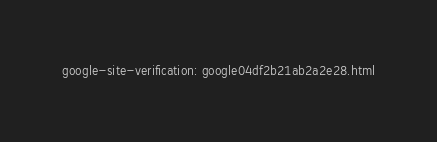<code> <loc_0><loc_0><loc_500><loc_500><_HTML_>google-site-verification: google04df2b21ab2a2e28.html</code> 